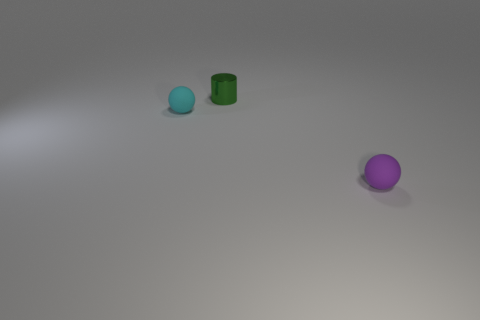Is there any other thing that is made of the same material as the cylinder?
Give a very brief answer. No. What number of other things are the same shape as the tiny shiny thing?
Offer a very short reply. 0. Are there any objects in front of the small cylinder?
Provide a short and direct response. Yes. How many cubes are green shiny things or rubber things?
Your answer should be compact. 0. Is the purple object the same shape as the tiny metallic object?
Provide a succinct answer. No. What size is the purple rubber object on the right side of the cylinder?
Make the answer very short. Small. There is a rubber thing behind the purple ball; does it have the same size as the metal thing?
Make the answer very short. Yes. What color is the cylinder?
Offer a terse response. Green. The small matte object that is in front of the tiny sphere that is on the left side of the purple matte thing is what color?
Ensure brevity in your answer.  Purple. Are there any small purple objects made of the same material as the tiny cyan object?
Your answer should be compact. Yes. 